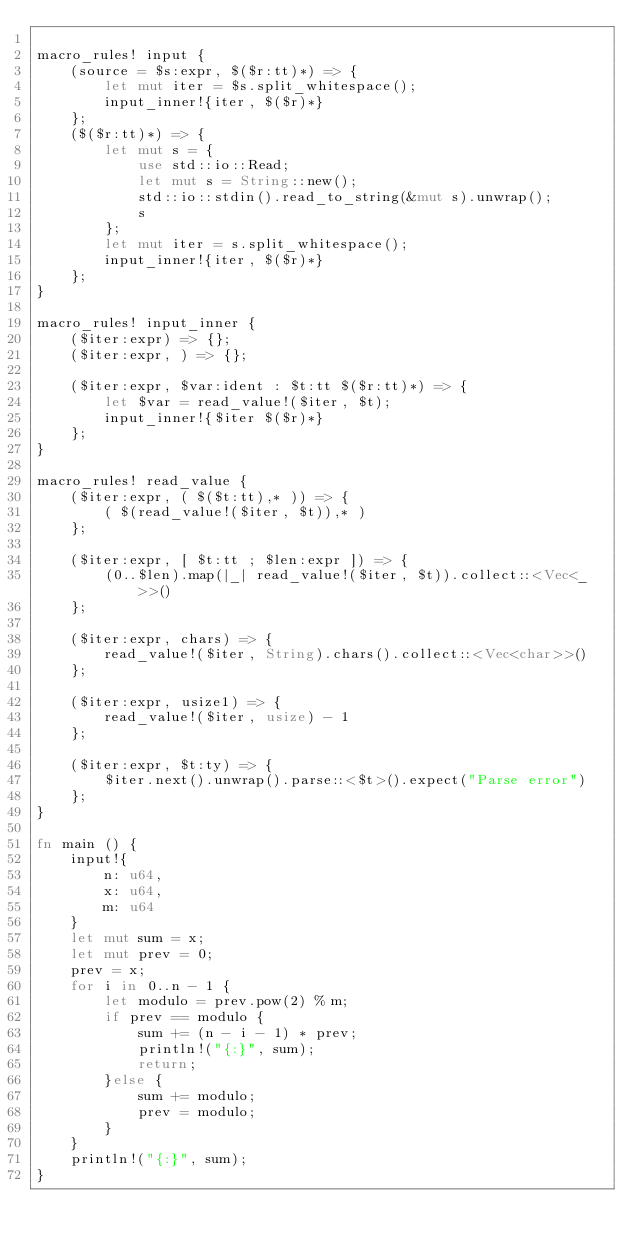<code> <loc_0><loc_0><loc_500><loc_500><_Rust_>
macro_rules! input {
    (source = $s:expr, $($r:tt)*) => {
        let mut iter = $s.split_whitespace();
        input_inner!{iter, $($r)*}
    };
    ($($r:tt)*) => {
        let mut s = {
            use std::io::Read;
            let mut s = String::new();
            std::io::stdin().read_to_string(&mut s).unwrap();
            s
        };
        let mut iter = s.split_whitespace();
        input_inner!{iter, $($r)*}
    };
}

macro_rules! input_inner {
    ($iter:expr) => {};
    ($iter:expr, ) => {};

    ($iter:expr, $var:ident : $t:tt $($r:tt)*) => {
        let $var = read_value!($iter, $t);
        input_inner!{$iter $($r)*}
    };
}

macro_rules! read_value {
    ($iter:expr, ( $($t:tt),* )) => {
        ( $(read_value!($iter, $t)),* )
    };

    ($iter:expr, [ $t:tt ; $len:expr ]) => {
        (0..$len).map(|_| read_value!($iter, $t)).collect::<Vec<_>>()
    };

    ($iter:expr, chars) => {
        read_value!($iter, String).chars().collect::<Vec<char>>()
    };

    ($iter:expr, usize1) => {
        read_value!($iter, usize) - 1
    };

    ($iter:expr, $t:ty) => {
        $iter.next().unwrap().parse::<$t>().expect("Parse error")
    };
}

fn main () {
    input!{
        n: u64,
        x: u64,
        m: u64
    }
    let mut sum = x;
    let mut prev = 0;
    prev = x;
    for i in 0..n - 1 {
        let modulo = prev.pow(2) % m;
        if prev == modulo {
            sum += (n - i - 1) * prev;
            println!("{:}", sum);
            return;
        }else {
            sum += modulo;
            prev = modulo;
        }
    }
    println!("{:}", sum);
}</code> 